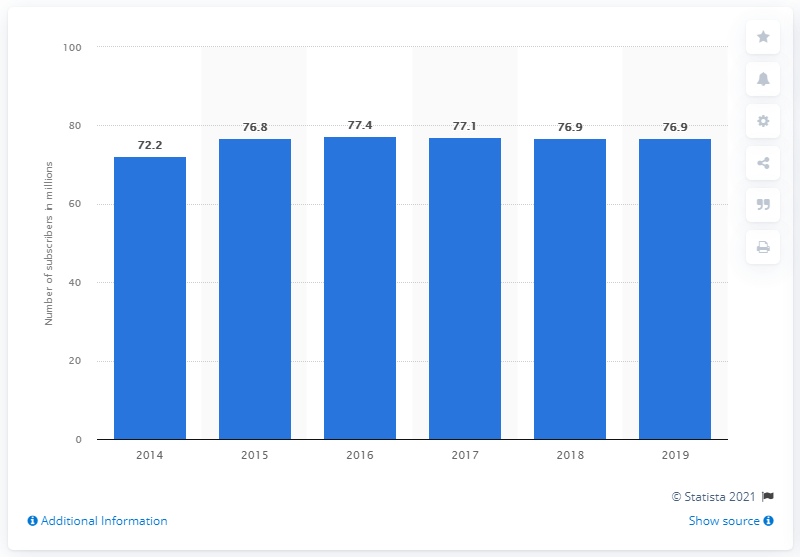List a handful of essential elements in this visual. In 2019, Megafon's subscriber base was approximately 76.9 million. 